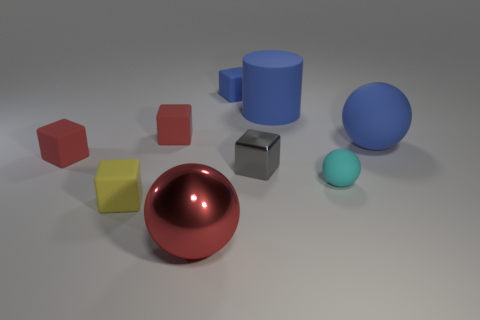What time of day does the lighting in the photo suggest? The lighting in the image appears artificial, as if illuminated by a single light source from above, which doesn't suggest a particular time of day. It is likely set up in a controlled environment, like a studio. 